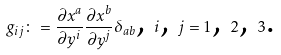<formula> <loc_0><loc_0><loc_500><loc_500>g _ { i j } \colon = \frac { \partial x ^ { a } } { \partial y ^ { i } } \frac { \partial x ^ { b } } { \partial y ^ { j } } \delta _ { a b } \text {, } i \text {, } j = 1 \text {, } 2 \text {, } 3 \text {.}</formula> 